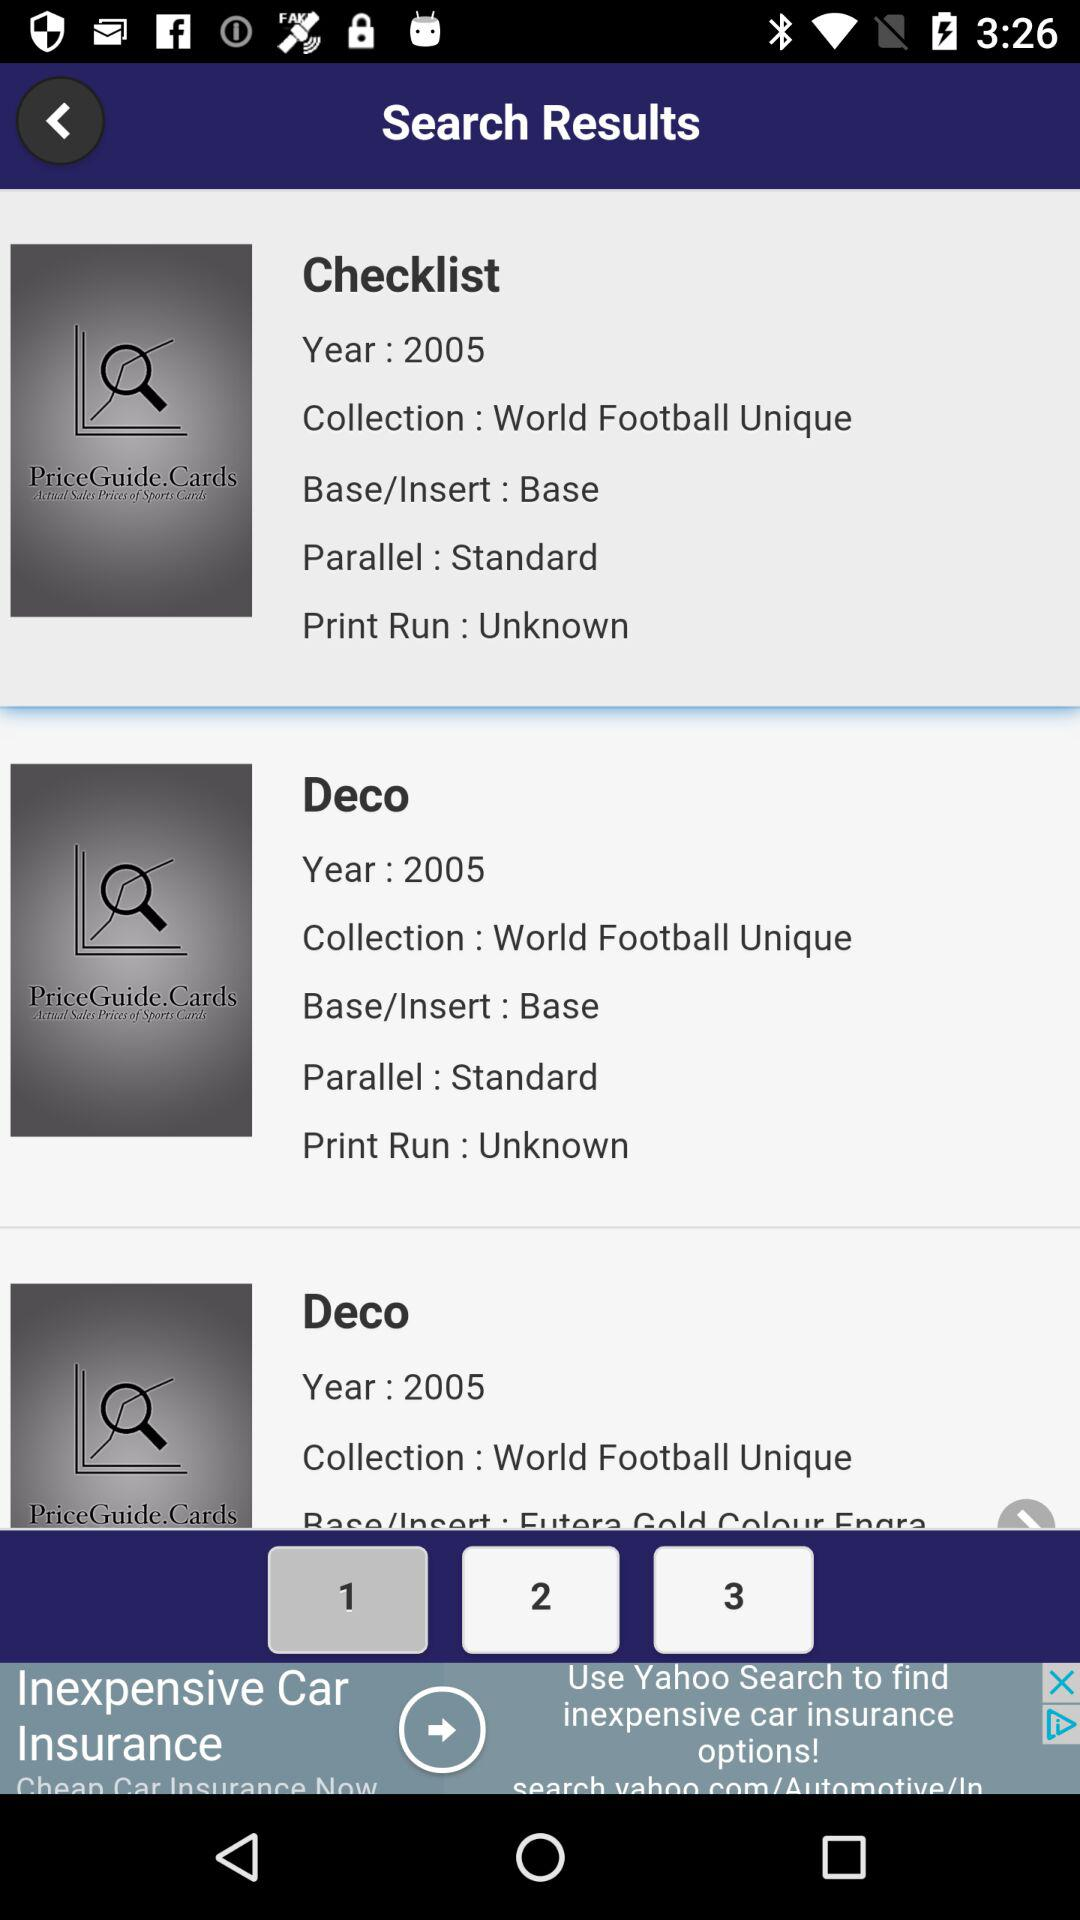How many collections are in tab 2?
When the provided information is insufficient, respond with <no answer>. <no answer> 